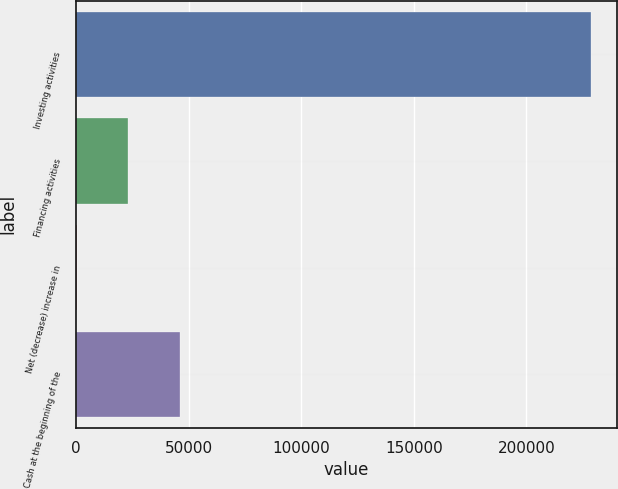<chart> <loc_0><loc_0><loc_500><loc_500><bar_chart><fcel>Investing activities<fcel>Financing activities<fcel>Net (decrease) increase in<fcel>Cash at the beginning of the<nl><fcel>228769<fcel>23129.8<fcel>281<fcel>45978.6<nl></chart> 